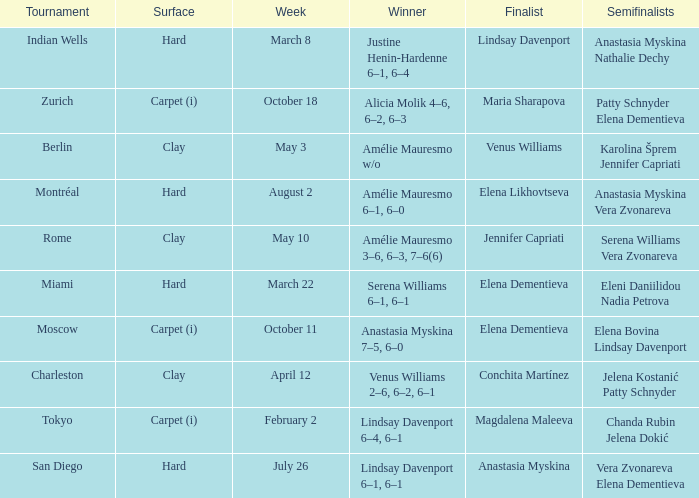Could you parse the entire table as a dict? {'header': ['Tournament', 'Surface', 'Week', 'Winner', 'Finalist', 'Semifinalists'], 'rows': [['Indian Wells', 'Hard', 'March 8', 'Justine Henin-Hardenne 6–1, 6–4', 'Lindsay Davenport', 'Anastasia Myskina Nathalie Dechy'], ['Zurich', 'Carpet (i)', 'October 18', 'Alicia Molik 4–6, 6–2, 6–3', 'Maria Sharapova', 'Patty Schnyder Elena Dementieva'], ['Berlin', 'Clay', 'May 3', 'Amélie Mauresmo w/o', 'Venus Williams', 'Karolina Šprem Jennifer Capriati'], ['Montréal', 'Hard', 'August 2', 'Amélie Mauresmo 6–1, 6–0', 'Elena Likhovtseva', 'Anastasia Myskina Vera Zvonareva'], ['Rome', 'Clay', 'May 10', 'Amélie Mauresmo 3–6, 6–3, 7–6(6)', 'Jennifer Capriati', 'Serena Williams Vera Zvonareva'], ['Miami', 'Hard', 'March 22', 'Serena Williams 6–1, 6–1', 'Elena Dementieva', 'Eleni Daniilidou Nadia Petrova'], ['Moscow', 'Carpet (i)', 'October 11', 'Anastasia Myskina 7–5, 6–0', 'Elena Dementieva', 'Elena Bovina Lindsay Davenport'], ['Charleston', 'Clay', 'April 12', 'Venus Williams 2–6, 6–2, 6–1', 'Conchita Martínez', 'Jelena Kostanić Patty Schnyder'], ['Tokyo', 'Carpet (i)', 'February 2', 'Lindsay Davenport 6–4, 6–1', 'Magdalena Maleeva', 'Chanda Rubin Jelena Dokić'], ['San Diego', 'Hard', 'July 26', 'Lindsay Davenport 6–1, 6–1', 'Anastasia Myskina', 'Vera Zvonareva Elena Dementieva']]} Who were the semifinalists in the Rome tournament? Serena Williams Vera Zvonareva. 